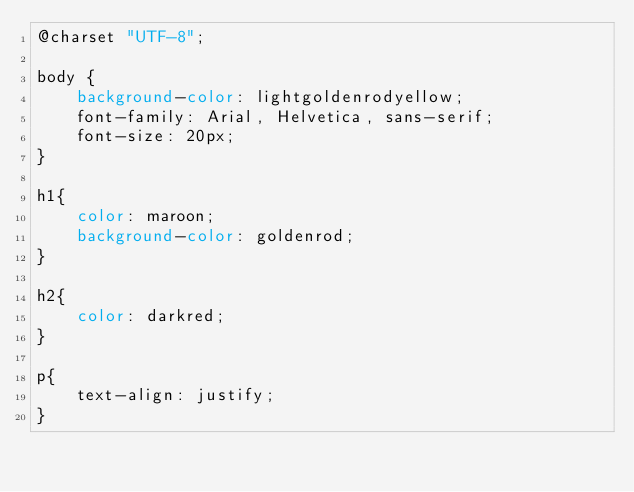<code> <loc_0><loc_0><loc_500><loc_500><_CSS_>@charset "UTF-8";

body {
    background-color: lightgoldenrodyellow;
    font-family: Arial, Helvetica, sans-serif;
    font-size: 20px;
}

h1{
    color: maroon;
    background-color: goldenrod;
}

h2{
    color: darkred;
}

p{
    text-align: justify;
}</code> 